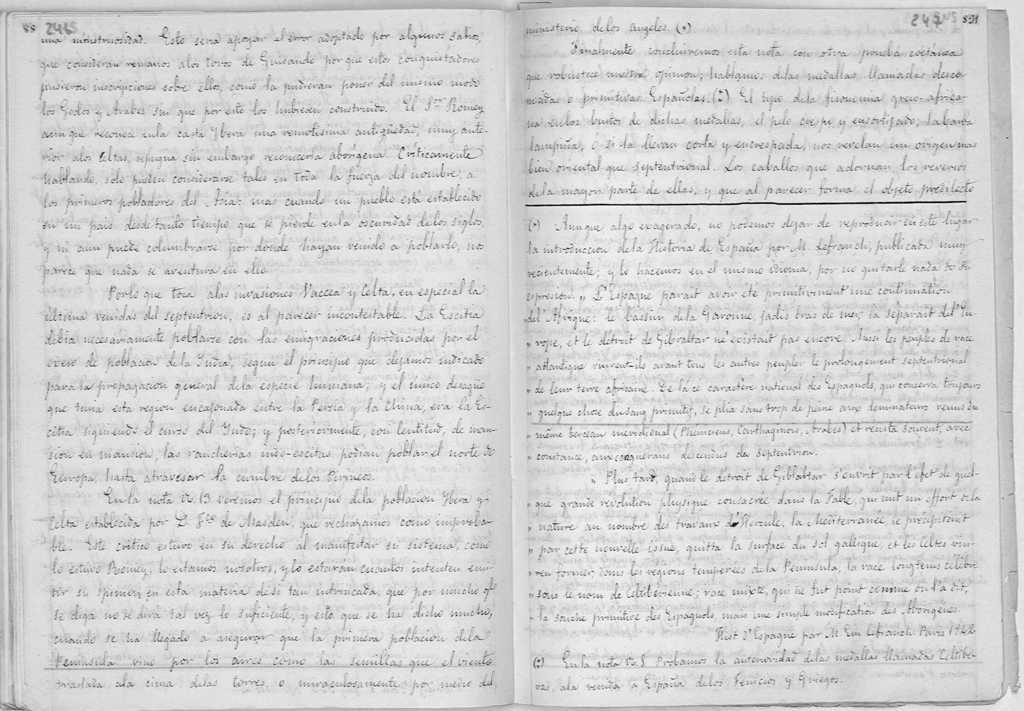What is present in the image that contains some information? There is a paper in the image. Can you describe what is written on the paper? The paper contains some text. Where is the box located in the image? There is no box present in the image. How many books are visible in the image? There are no books visible in the image. Is there a carriage in the image? There is no carriage present in the image. 